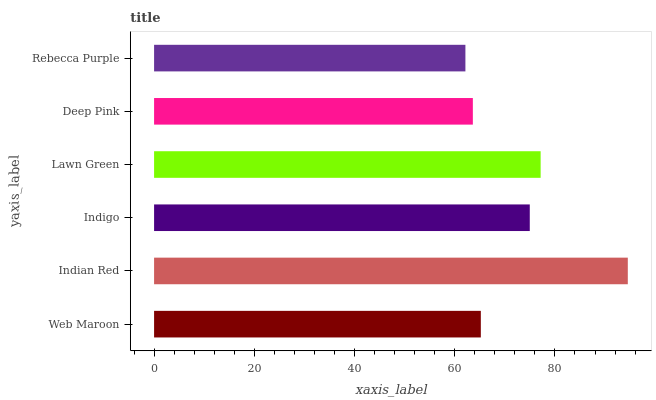Is Rebecca Purple the minimum?
Answer yes or no. Yes. Is Indian Red the maximum?
Answer yes or no. Yes. Is Indigo the minimum?
Answer yes or no. No. Is Indigo the maximum?
Answer yes or no. No. Is Indian Red greater than Indigo?
Answer yes or no. Yes. Is Indigo less than Indian Red?
Answer yes or no. Yes. Is Indigo greater than Indian Red?
Answer yes or no. No. Is Indian Red less than Indigo?
Answer yes or no. No. Is Indigo the high median?
Answer yes or no. Yes. Is Web Maroon the low median?
Answer yes or no. Yes. Is Deep Pink the high median?
Answer yes or no. No. Is Indigo the low median?
Answer yes or no. No. 